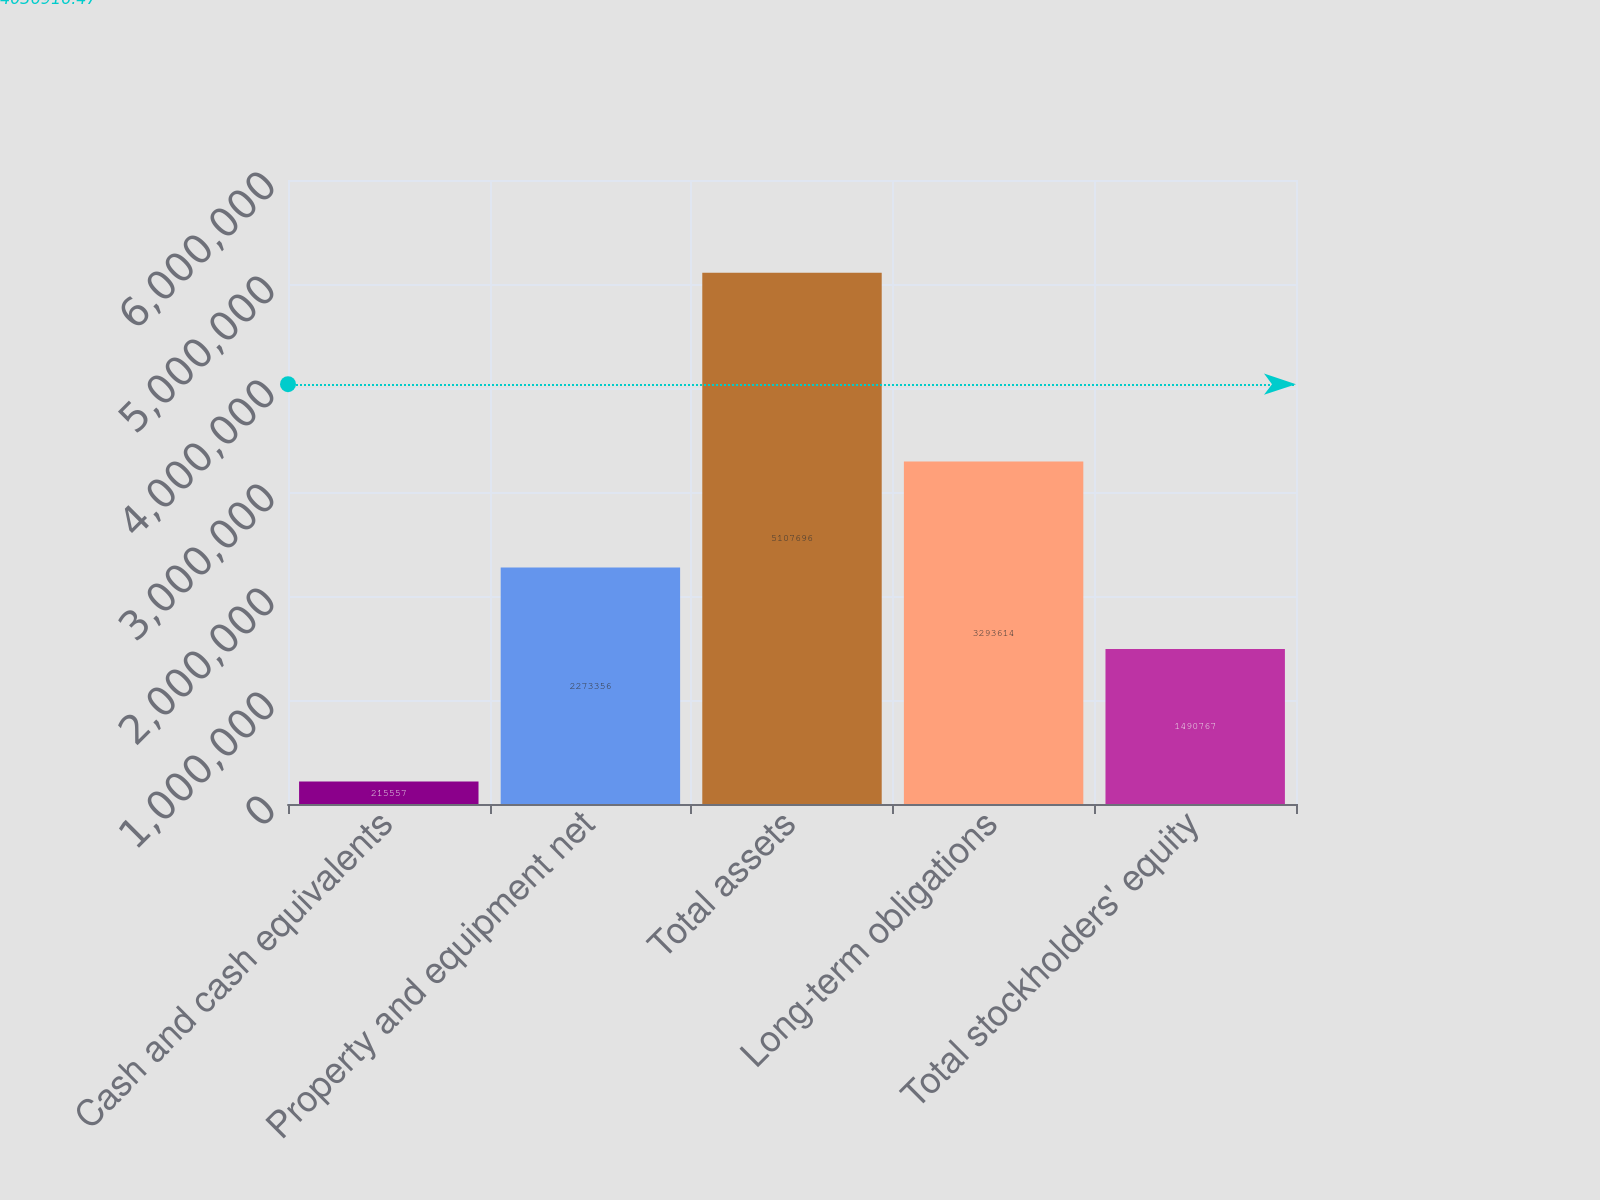Convert chart. <chart><loc_0><loc_0><loc_500><loc_500><bar_chart><fcel>Cash and cash equivalents<fcel>Property and equipment net<fcel>Total assets<fcel>Long-term obligations<fcel>Total stockholders' equity<nl><fcel>215557<fcel>2.27336e+06<fcel>5.1077e+06<fcel>3.29361e+06<fcel>1.49077e+06<nl></chart> 